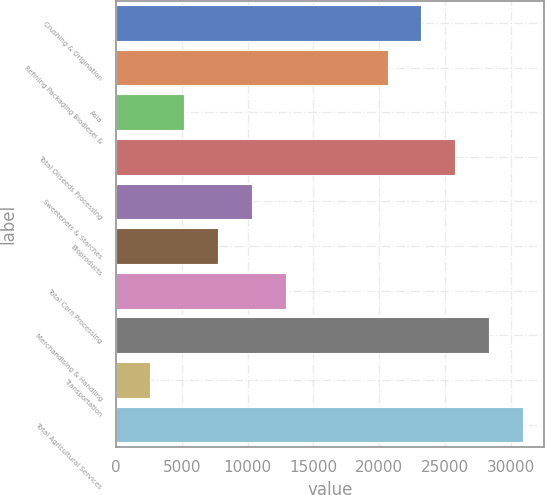Convert chart. <chart><loc_0><loc_0><loc_500><loc_500><bar_chart><fcel>Crushing & Origination<fcel>Refining Packaging Biodiesel &<fcel>Asia<fcel>Total Oilseeds Processing<fcel>Sweeteners & Starches<fcel>Bioproducts<fcel>Total Corn Processing<fcel>Merchandising & Handling<fcel>Transportation<fcel>Total Agricultural Services<nl><fcel>23218.6<fcel>20639.2<fcel>5162.8<fcel>25798<fcel>10321.6<fcel>7742.2<fcel>12901<fcel>28377.4<fcel>2583.4<fcel>30956.8<nl></chart> 